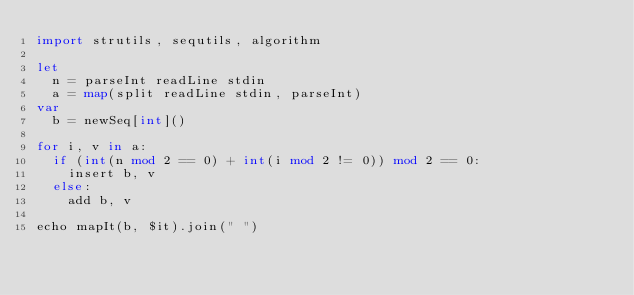Convert code to text. <code><loc_0><loc_0><loc_500><loc_500><_Nim_>import strutils, sequtils, algorithm

let
  n = parseInt readLine stdin
  a = map(split readLine stdin, parseInt)
var
  b = newSeq[int]()

for i, v in a:
  if (int(n mod 2 == 0) + int(i mod 2 != 0)) mod 2 == 0:
    insert b, v
  else:
    add b, v

echo mapIt(b, $it).join(" ")
</code> 